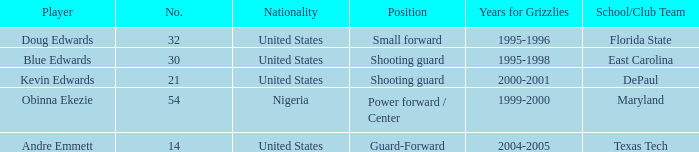Which position did kevin edwards play for Shooting guard. 